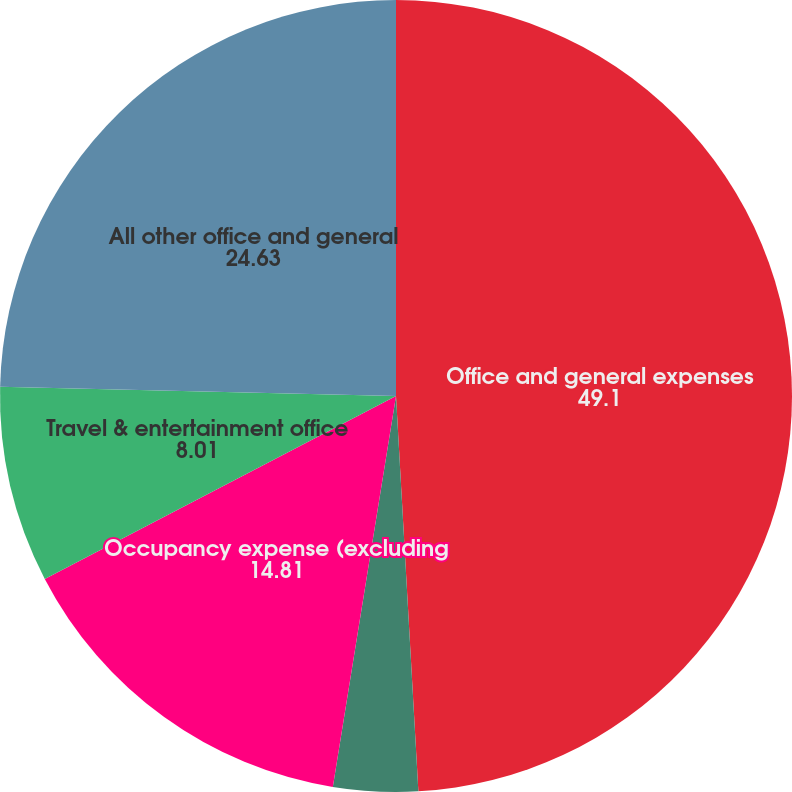Convert chart to OTSL. <chart><loc_0><loc_0><loc_500><loc_500><pie_chart><fcel>Office and general expenses<fcel>Professional fees<fcel>Occupancy expense (excluding<fcel>Travel & entertainment office<fcel>All other office and general<nl><fcel>49.1%<fcel>3.45%<fcel>14.81%<fcel>8.01%<fcel>24.63%<nl></chart> 